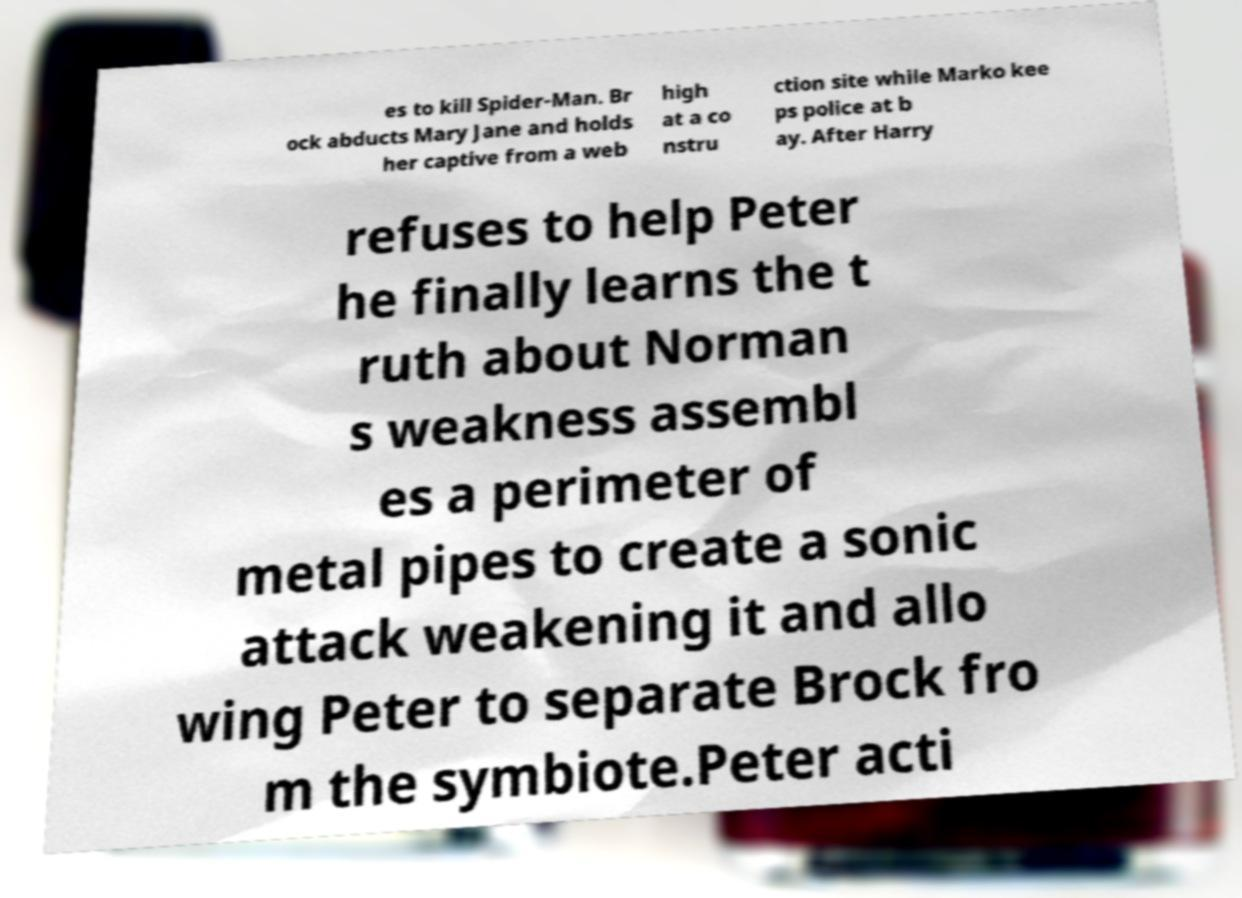I need the written content from this picture converted into text. Can you do that? es to kill Spider-Man. Br ock abducts Mary Jane and holds her captive from a web high at a co nstru ction site while Marko kee ps police at b ay. After Harry refuses to help Peter he finally learns the t ruth about Norman s weakness assembl es a perimeter of metal pipes to create a sonic attack weakening it and allo wing Peter to separate Brock fro m the symbiote.Peter acti 